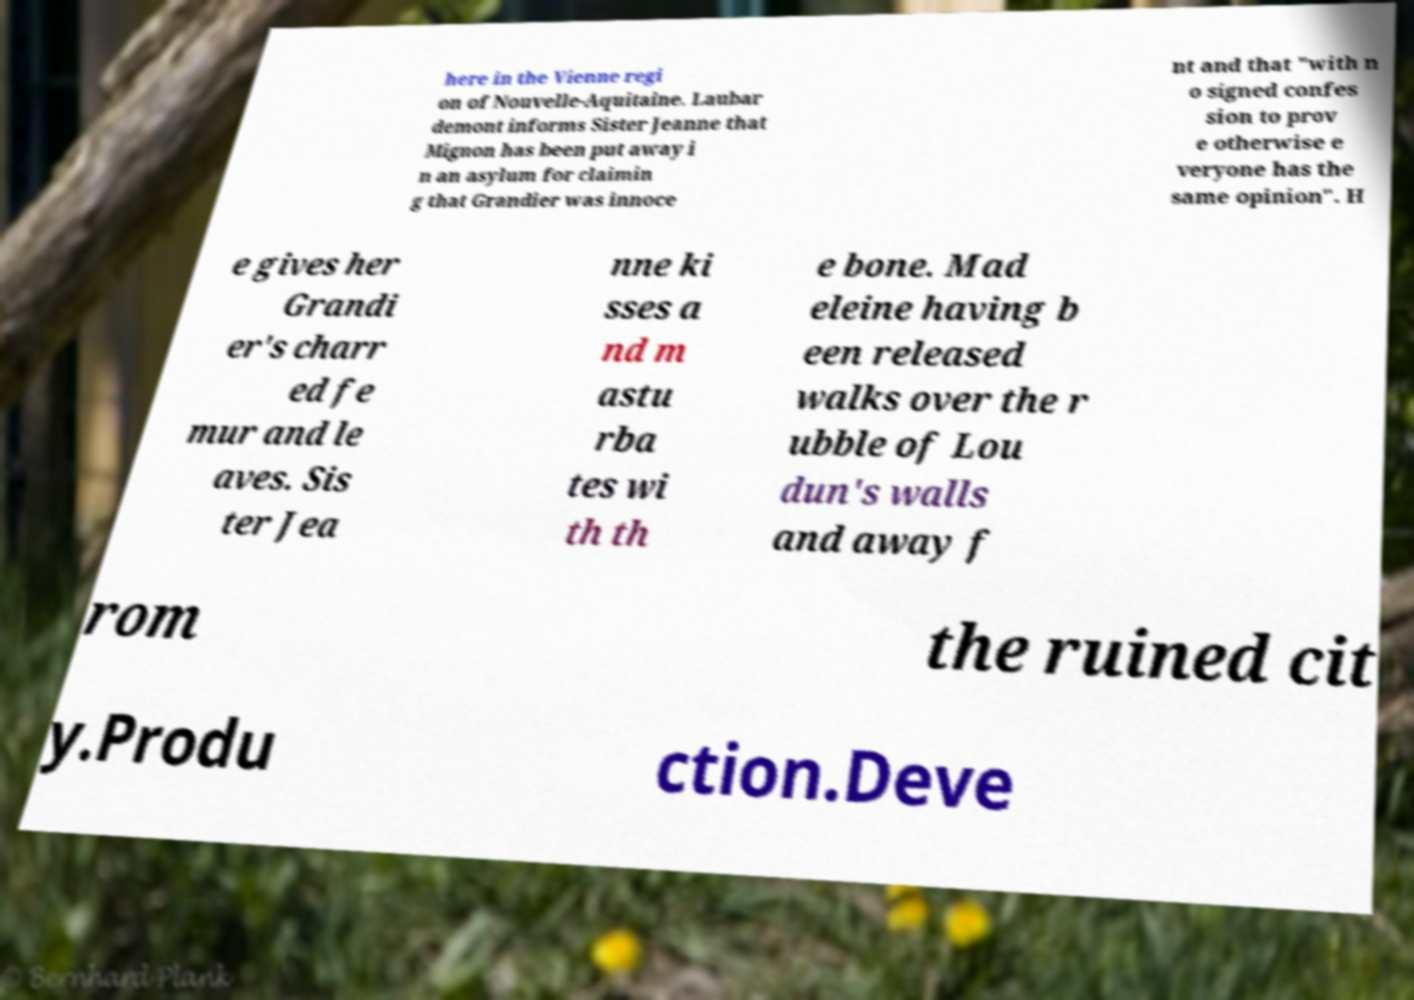Could you extract and type out the text from this image? here in the Vienne regi on of Nouvelle-Aquitaine. Laubar demont informs Sister Jeanne that Mignon has been put away i n an asylum for claimin g that Grandier was innoce nt and that "with n o signed confes sion to prov e otherwise e veryone has the same opinion". H e gives her Grandi er's charr ed fe mur and le aves. Sis ter Jea nne ki sses a nd m astu rba tes wi th th e bone. Mad eleine having b een released walks over the r ubble of Lou dun's walls and away f rom the ruined cit y.Produ ction.Deve 